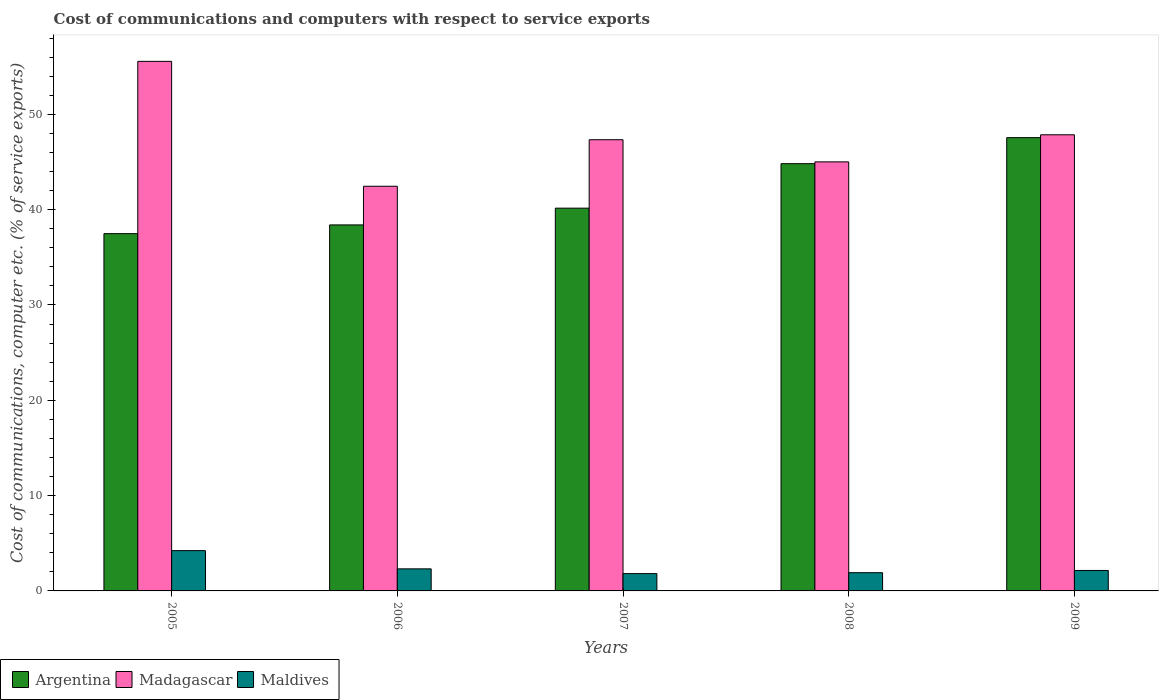How many groups of bars are there?
Your response must be concise. 5. Are the number of bars per tick equal to the number of legend labels?
Provide a succinct answer. Yes. In how many cases, is the number of bars for a given year not equal to the number of legend labels?
Offer a very short reply. 0. What is the cost of communications and computers in Maldives in 2007?
Your answer should be compact. 1.82. Across all years, what is the maximum cost of communications and computers in Madagascar?
Your answer should be compact. 55.56. Across all years, what is the minimum cost of communications and computers in Argentina?
Your answer should be compact. 37.49. In which year was the cost of communications and computers in Maldives maximum?
Offer a terse response. 2005. What is the total cost of communications and computers in Madagascar in the graph?
Offer a terse response. 238.24. What is the difference between the cost of communications and computers in Maldives in 2005 and that in 2006?
Your response must be concise. 1.91. What is the difference between the cost of communications and computers in Maldives in 2008 and the cost of communications and computers in Madagascar in 2006?
Provide a short and direct response. -40.55. What is the average cost of communications and computers in Madagascar per year?
Make the answer very short. 47.65. In the year 2006, what is the difference between the cost of communications and computers in Madagascar and cost of communications and computers in Maldives?
Your answer should be compact. 40.14. What is the ratio of the cost of communications and computers in Argentina in 2005 to that in 2009?
Give a very brief answer. 0.79. Is the difference between the cost of communications and computers in Madagascar in 2007 and 2008 greater than the difference between the cost of communications and computers in Maldives in 2007 and 2008?
Give a very brief answer. Yes. What is the difference between the highest and the second highest cost of communications and computers in Maldives?
Your answer should be compact. 1.91. What is the difference between the highest and the lowest cost of communications and computers in Argentina?
Make the answer very short. 10.07. In how many years, is the cost of communications and computers in Argentina greater than the average cost of communications and computers in Argentina taken over all years?
Offer a very short reply. 2. What does the 1st bar from the left in 2008 represents?
Keep it short and to the point. Argentina. How many years are there in the graph?
Offer a terse response. 5. What is the difference between two consecutive major ticks on the Y-axis?
Make the answer very short. 10. Where does the legend appear in the graph?
Offer a terse response. Bottom left. How many legend labels are there?
Your response must be concise. 3. What is the title of the graph?
Offer a very short reply. Cost of communications and computers with respect to service exports. Does "Iceland" appear as one of the legend labels in the graph?
Your answer should be compact. No. What is the label or title of the X-axis?
Offer a terse response. Years. What is the label or title of the Y-axis?
Your answer should be compact. Cost of communications, computer etc. (% of service exports). What is the Cost of communications, computer etc. (% of service exports) of Argentina in 2005?
Ensure brevity in your answer.  37.49. What is the Cost of communications, computer etc. (% of service exports) in Madagascar in 2005?
Give a very brief answer. 55.56. What is the Cost of communications, computer etc. (% of service exports) of Maldives in 2005?
Keep it short and to the point. 4.23. What is the Cost of communications, computer etc. (% of service exports) of Argentina in 2006?
Offer a terse response. 38.4. What is the Cost of communications, computer etc. (% of service exports) of Madagascar in 2006?
Your answer should be compact. 42.46. What is the Cost of communications, computer etc. (% of service exports) in Maldives in 2006?
Make the answer very short. 2.32. What is the Cost of communications, computer etc. (% of service exports) in Argentina in 2007?
Provide a succinct answer. 40.16. What is the Cost of communications, computer etc. (% of service exports) of Madagascar in 2007?
Give a very brief answer. 47.34. What is the Cost of communications, computer etc. (% of service exports) in Maldives in 2007?
Your answer should be very brief. 1.82. What is the Cost of communications, computer etc. (% of service exports) of Argentina in 2008?
Your response must be concise. 44.83. What is the Cost of communications, computer etc. (% of service exports) of Madagascar in 2008?
Your answer should be compact. 45.02. What is the Cost of communications, computer etc. (% of service exports) in Maldives in 2008?
Keep it short and to the point. 1.91. What is the Cost of communications, computer etc. (% of service exports) of Argentina in 2009?
Your response must be concise. 47.56. What is the Cost of communications, computer etc. (% of service exports) in Madagascar in 2009?
Provide a short and direct response. 47.86. What is the Cost of communications, computer etc. (% of service exports) in Maldives in 2009?
Provide a succinct answer. 2.15. Across all years, what is the maximum Cost of communications, computer etc. (% of service exports) of Argentina?
Provide a short and direct response. 47.56. Across all years, what is the maximum Cost of communications, computer etc. (% of service exports) in Madagascar?
Your response must be concise. 55.56. Across all years, what is the maximum Cost of communications, computer etc. (% of service exports) of Maldives?
Keep it short and to the point. 4.23. Across all years, what is the minimum Cost of communications, computer etc. (% of service exports) in Argentina?
Your response must be concise. 37.49. Across all years, what is the minimum Cost of communications, computer etc. (% of service exports) in Madagascar?
Offer a very short reply. 42.46. Across all years, what is the minimum Cost of communications, computer etc. (% of service exports) of Maldives?
Your answer should be compact. 1.82. What is the total Cost of communications, computer etc. (% of service exports) of Argentina in the graph?
Offer a terse response. 208.43. What is the total Cost of communications, computer etc. (% of service exports) of Madagascar in the graph?
Your response must be concise. 238.24. What is the total Cost of communications, computer etc. (% of service exports) of Maldives in the graph?
Make the answer very short. 12.42. What is the difference between the Cost of communications, computer etc. (% of service exports) of Argentina in 2005 and that in 2006?
Offer a very short reply. -0.92. What is the difference between the Cost of communications, computer etc. (% of service exports) of Madagascar in 2005 and that in 2006?
Keep it short and to the point. 13.1. What is the difference between the Cost of communications, computer etc. (% of service exports) in Maldives in 2005 and that in 2006?
Offer a terse response. 1.91. What is the difference between the Cost of communications, computer etc. (% of service exports) of Argentina in 2005 and that in 2007?
Ensure brevity in your answer.  -2.67. What is the difference between the Cost of communications, computer etc. (% of service exports) of Madagascar in 2005 and that in 2007?
Ensure brevity in your answer.  8.22. What is the difference between the Cost of communications, computer etc. (% of service exports) of Maldives in 2005 and that in 2007?
Your answer should be compact. 2.41. What is the difference between the Cost of communications, computer etc. (% of service exports) in Argentina in 2005 and that in 2008?
Ensure brevity in your answer.  -7.34. What is the difference between the Cost of communications, computer etc. (% of service exports) of Madagascar in 2005 and that in 2008?
Give a very brief answer. 10.55. What is the difference between the Cost of communications, computer etc. (% of service exports) in Maldives in 2005 and that in 2008?
Your response must be concise. 2.32. What is the difference between the Cost of communications, computer etc. (% of service exports) of Argentina in 2005 and that in 2009?
Make the answer very short. -10.07. What is the difference between the Cost of communications, computer etc. (% of service exports) of Madagascar in 2005 and that in 2009?
Make the answer very short. 7.7. What is the difference between the Cost of communications, computer etc. (% of service exports) in Maldives in 2005 and that in 2009?
Offer a very short reply. 2.08. What is the difference between the Cost of communications, computer etc. (% of service exports) in Argentina in 2006 and that in 2007?
Your response must be concise. -1.76. What is the difference between the Cost of communications, computer etc. (% of service exports) in Madagascar in 2006 and that in 2007?
Provide a short and direct response. -4.88. What is the difference between the Cost of communications, computer etc. (% of service exports) in Maldives in 2006 and that in 2007?
Offer a very short reply. 0.5. What is the difference between the Cost of communications, computer etc. (% of service exports) of Argentina in 2006 and that in 2008?
Ensure brevity in your answer.  -6.42. What is the difference between the Cost of communications, computer etc. (% of service exports) of Madagascar in 2006 and that in 2008?
Offer a terse response. -2.56. What is the difference between the Cost of communications, computer etc. (% of service exports) of Maldives in 2006 and that in 2008?
Offer a very short reply. 0.4. What is the difference between the Cost of communications, computer etc. (% of service exports) of Argentina in 2006 and that in 2009?
Offer a terse response. -9.16. What is the difference between the Cost of communications, computer etc. (% of service exports) in Madagascar in 2006 and that in 2009?
Give a very brief answer. -5.4. What is the difference between the Cost of communications, computer etc. (% of service exports) of Maldives in 2006 and that in 2009?
Offer a terse response. 0.17. What is the difference between the Cost of communications, computer etc. (% of service exports) of Argentina in 2007 and that in 2008?
Provide a succinct answer. -4.67. What is the difference between the Cost of communications, computer etc. (% of service exports) in Madagascar in 2007 and that in 2008?
Keep it short and to the point. 2.32. What is the difference between the Cost of communications, computer etc. (% of service exports) of Maldives in 2007 and that in 2008?
Ensure brevity in your answer.  -0.09. What is the difference between the Cost of communications, computer etc. (% of service exports) of Argentina in 2007 and that in 2009?
Make the answer very short. -7.4. What is the difference between the Cost of communications, computer etc. (% of service exports) in Madagascar in 2007 and that in 2009?
Make the answer very short. -0.52. What is the difference between the Cost of communications, computer etc. (% of service exports) in Maldives in 2007 and that in 2009?
Give a very brief answer. -0.33. What is the difference between the Cost of communications, computer etc. (% of service exports) in Argentina in 2008 and that in 2009?
Make the answer very short. -2.73. What is the difference between the Cost of communications, computer etc. (% of service exports) of Madagascar in 2008 and that in 2009?
Provide a succinct answer. -2.84. What is the difference between the Cost of communications, computer etc. (% of service exports) of Maldives in 2008 and that in 2009?
Offer a very short reply. -0.24. What is the difference between the Cost of communications, computer etc. (% of service exports) of Argentina in 2005 and the Cost of communications, computer etc. (% of service exports) of Madagascar in 2006?
Provide a succinct answer. -4.97. What is the difference between the Cost of communications, computer etc. (% of service exports) in Argentina in 2005 and the Cost of communications, computer etc. (% of service exports) in Maldives in 2006?
Offer a very short reply. 35.17. What is the difference between the Cost of communications, computer etc. (% of service exports) of Madagascar in 2005 and the Cost of communications, computer etc. (% of service exports) of Maldives in 2006?
Keep it short and to the point. 53.25. What is the difference between the Cost of communications, computer etc. (% of service exports) of Argentina in 2005 and the Cost of communications, computer etc. (% of service exports) of Madagascar in 2007?
Make the answer very short. -9.86. What is the difference between the Cost of communications, computer etc. (% of service exports) of Argentina in 2005 and the Cost of communications, computer etc. (% of service exports) of Maldives in 2007?
Offer a very short reply. 35.67. What is the difference between the Cost of communications, computer etc. (% of service exports) of Madagascar in 2005 and the Cost of communications, computer etc. (% of service exports) of Maldives in 2007?
Provide a succinct answer. 53.75. What is the difference between the Cost of communications, computer etc. (% of service exports) of Argentina in 2005 and the Cost of communications, computer etc. (% of service exports) of Madagascar in 2008?
Offer a very short reply. -7.53. What is the difference between the Cost of communications, computer etc. (% of service exports) in Argentina in 2005 and the Cost of communications, computer etc. (% of service exports) in Maldives in 2008?
Provide a short and direct response. 35.57. What is the difference between the Cost of communications, computer etc. (% of service exports) of Madagascar in 2005 and the Cost of communications, computer etc. (% of service exports) of Maldives in 2008?
Your response must be concise. 53.65. What is the difference between the Cost of communications, computer etc. (% of service exports) of Argentina in 2005 and the Cost of communications, computer etc. (% of service exports) of Madagascar in 2009?
Offer a very short reply. -10.37. What is the difference between the Cost of communications, computer etc. (% of service exports) of Argentina in 2005 and the Cost of communications, computer etc. (% of service exports) of Maldives in 2009?
Offer a terse response. 35.34. What is the difference between the Cost of communications, computer etc. (% of service exports) of Madagascar in 2005 and the Cost of communications, computer etc. (% of service exports) of Maldives in 2009?
Keep it short and to the point. 53.42. What is the difference between the Cost of communications, computer etc. (% of service exports) in Argentina in 2006 and the Cost of communications, computer etc. (% of service exports) in Madagascar in 2007?
Offer a very short reply. -8.94. What is the difference between the Cost of communications, computer etc. (% of service exports) in Argentina in 2006 and the Cost of communications, computer etc. (% of service exports) in Maldives in 2007?
Ensure brevity in your answer.  36.58. What is the difference between the Cost of communications, computer etc. (% of service exports) of Madagascar in 2006 and the Cost of communications, computer etc. (% of service exports) of Maldives in 2007?
Give a very brief answer. 40.64. What is the difference between the Cost of communications, computer etc. (% of service exports) of Argentina in 2006 and the Cost of communications, computer etc. (% of service exports) of Madagascar in 2008?
Give a very brief answer. -6.61. What is the difference between the Cost of communications, computer etc. (% of service exports) of Argentina in 2006 and the Cost of communications, computer etc. (% of service exports) of Maldives in 2008?
Provide a short and direct response. 36.49. What is the difference between the Cost of communications, computer etc. (% of service exports) of Madagascar in 2006 and the Cost of communications, computer etc. (% of service exports) of Maldives in 2008?
Make the answer very short. 40.55. What is the difference between the Cost of communications, computer etc. (% of service exports) of Argentina in 2006 and the Cost of communications, computer etc. (% of service exports) of Madagascar in 2009?
Your answer should be very brief. -9.46. What is the difference between the Cost of communications, computer etc. (% of service exports) in Argentina in 2006 and the Cost of communications, computer etc. (% of service exports) in Maldives in 2009?
Offer a very short reply. 36.26. What is the difference between the Cost of communications, computer etc. (% of service exports) of Madagascar in 2006 and the Cost of communications, computer etc. (% of service exports) of Maldives in 2009?
Offer a very short reply. 40.31. What is the difference between the Cost of communications, computer etc. (% of service exports) of Argentina in 2007 and the Cost of communications, computer etc. (% of service exports) of Madagascar in 2008?
Your answer should be very brief. -4.86. What is the difference between the Cost of communications, computer etc. (% of service exports) in Argentina in 2007 and the Cost of communications, computer etc. (% of service exports) in Maldives in 2008?
Keep it short and to the point. 38.25. What is the difference between the Cost of communications, computer etc. (% of service exports) in Madagascar in 2007 and the Cost of communications, computer etc. (% of service exports) in Maldives in 2008?
Make the answer very short. 45.43. What is the difference between the Cost of communications, computer etc. (% of service exports) of Argentina in 2007 and the Cost of communications, computer etc. (% of service exports) of Madagascar in 2009?
Provide a short and direct response. -7.7. What is the difference between the Cost of communications, computer etc. (% of service exports) in Argentina in 2007 and the Cost of communications, computer etc. (% of service exports) in Maldives in 2009?
Offer a terse response. 38.01. What is the difference between the Cost of communications, computer etc. (% of service exports) of Madagascar in 2007 and the Cost of communications, computer etc. (% of service exports) of Maldives in 2009?
Offer a terse response. 45.19. What is the difference between the Cost of communications, computer etc. (% of service exports) of Argentina in 2008 and the Cost of communications, computer etc. (% of service exports) of Madagascar in 2009?
Keep it short and to the point. -3.03. What is the difference between the Cost of communications, computer etc. (% of service exports) in Argentina in 2008 and the Cost of communications, computer etc. (% of service exports) in Maldives in 2009?
Give a very brief answer. 42.68. What is the difference between the Cost of communications, computer etc. (% of service exports) in Madagascar in 2008 and the Cost of communications, computer etc. (% of service exports) in Maldives in 2009?
Make the answer very short. 42.87. What is the average Cost of communications, computer etc. (% of service exports) of Argentina per year?
Offer a very short reply. 41.69. What is the average Cost of communications, computer etc. (% of service exports) in Madagascar per year?
Make the answer very short. 47.65. What is the average Cost of communications, computer etc. (% of service exports) in Maldives per year?
Ensure brevity in your answer.  2.48. In the year 2005, what is the difference between the Cost of communications, computer etc. (% of service exports) of Argentina and Cost of communications, computer etc. (% of service exports) of Madagascar?
Provide a short and direct response. -18.08. In the year 2005, what is the difference between the Cost of communications, computer etc. (% of service exports) of Argentina and Cost of communications, computer etc. (% of service exports) of Maldives?
Your response must be concise. 33.26. In the year 2005, what is the difference between the Cost of communications, computer etc. (% of service exports) of Madagascar and Cost of communications, computer etc. (% of service exports) of Maldives?
Give a very brief answer. 51.34. In the year 2006, what is the difference between the Cost of communications, computer etc. (% of service exports) in Argentina and Cost of communications, computer etc. (% of service exports) in Madagascar?
Give a very brief answer. -4.06. In the year 2006, what is the difference between the Cost of communications, computer etc. (% of service exports) in Argentina and Cost of communications, computer etc. (% of service exports) in Maldives?
Your answer should be very brief. 36.09. In the year 2006, what is the difference between the Cost of communications, computer etc. (% of service exports) of Madagascar and Cost of communications, computer etc. (% of service exports) of Maldives?
Your answer should be compact. 40.14. In the year 2007, what is the difference between the Cost of communications, computer etc. (% of service exports) of Argentina and Cost of communications, computer etc. (% of service exports) of Madagascar?
Make the answer very short. -7.18. In the year 2007, what is the difference between the Cost of communications, computer etc. (% of service exports) of Argentina and Cost of communications, computer etc. (% of service exports) of Maldives?
Offer a terse response. 38.34. In the year 2007, what is the difference between the Cost of communications, computer etc. (% of service exports) of Madagascar and Cost of communications, computer etc. (% of service exports) of Maldives?
Provide a succinct answer. 45.52. In the year 2008, what is the difference between the Cost of communications, computer etc. (% of service exports) of Argentina and Cost of communications, computer etc. (% of service exports) of Madagascar?
Provide a succinct answer. -0.19. In the year 2008, what is the difference between the Cost of communications, computer etc. (% of service exports) of Argentina and Cost of communications, computer etc. (% of service exports) of Maldives?
Offer a very short reply. 42.91. In the year 2008, what is the difference between the Cost of communications, computer etc. (% of service exports) of Madagascar and Cost of communications, computer etc. (% of service exports) of Maldives?
Provide a short and direct response. 43.1. In the year 2009, what is the difference between the Cost of communications, computer etc. (% of service exports) of Argentina and Cost of communications, computer etc. (% of service exports) of Madagascar?
Your answer should be compact. -0.3. In the year 2009, what is the difference between the Cost of communications, computer etc. (% of service exports) in Argentina and Cost of communications, computer etc. (% of service exports) in Maldives?
Your response must be concise. 45.41. In the year 2009, what is the difference between the Cost of communications, computer etc. (% of service exports) of Madagascar and Cost of communications, computer etc. (% of service exports) of Maldives?
Make the answer very short. 45.71. What is the ratio of the Cost of communications, computer etc. (% of service exports) of Argentina in 2005 to that in 2006?
Give a very brief answer. 0.98. What is the ratio of the Cost of communications, computer etc. (% of service exports) in Madagascar in 2005 to that in 2006?
Make the answer very short. 1.31. What is the ratio of the Cost of communications, computer etc. (% of service exports) of Maldives in 2005 to that in 2006?
Keep it short and to the point. 1.83. What is the ratio of the Cost of communications, computer etc. (% of service exports) in Argentina in 2005 to that in 2007?
Provide a short and direct response. 0.93. What is the ratio of the Cost of communications, computer etc. (% of service exports) in Madagascar in 2005 to that in 2007?
Your answer should be compact. 1.17. What is the ratio of the Cost of communications, computer etc. (% of service exports) of Maldives in 2005 to that in 2007?
Provide a short and direct response. 2.33. What is the ratio of the Cost of communications, computer etc. (% of service exports) of Argentina in 2005 to that in 2008?
Your answer should be very brief. 0.84. What is the ratio of the Cost of communications, computer etc. (% of service exports) in Madagascar in 2005 to that in 2008?
Give a very brief answer. 1.23. What is the ratio of the Cost of communications, computer etc. (% of service exports) in Maldives in 2005 to that in 2008?
Provide a succinct answer. 2.21. What is the ratio of the Cost of communications, computer etc. (% of service exports) in Argentina in 2005 to that in 2009?
Make the answer very short. 0.79. What is the ratio of the Cost of communications, computer etc. (% of service exports) of Madagascar in 2005 to that in 2009?
Your answer should be compact. 1.16. What is the ratio of the Cost of communications, computer etc. (% of service exports) in Maldives in 2005 to that in 2009?
Make the answer very short. 1.97. What is the ratio of the Cost of communications, computer etc. (% of service exports) of Argentina in 2006 to that in 2007?
Provide a succinct answer. 0.96. What is the ratio of the Cost of communications, computer etc. (% of service exports) in Madagascar in 2006 to that in 2007?
Keep it short and to the point. 0.9. What is the ratio of the Cost of communications, computer etc. (% of service exports) in Maldives in 2006 to that in 2007?
Keep it short and to the point. 1.27. What is the ratio of the Cost of communications, computer etc. (% of service exports) in Argentina in 2006 to that in 2008?
Offer a very short reply. 0.86. What is the ratio of the Cost of communications, computer etc. (% of service exports) in Madagascar in 2006 to that in 2008?
Make the answer very short. 0.94. What is the ratio of the Cost of communications, computer etc. (% of service exports) of Maldives in 2006 to that in 2008?
Give a very brief answer. 1.21. What is the ratio of the Cost of communications, computer etc. (% of service exports) in Argentina in 2006 to that in 2009?
Provide a short and direct response. 0.81. What is the ratio of the Cost of communications, computer etc. (% of service exports) of Madagascar in 2006 to that in 2009?
Give a very brief answer. 0.89. What is the ratio of the Cost of communications, computer etc. (% of service exports) of Maldives in 2006 to that in 2009?
Offer a terse response. 1.08. What is the ratio of the Cost of communications, computer etc. (% of service exports) in Argentina in 2007 to that in 2008?
Provide a succinct answer. 0.9. What is the ratio of the Cost of communications, computer etc. (% of service exports) of Madagascar in 2007 to that in 2008?
Your answer should be compact. 1.05. What is the ratio of the Cost of communications, computer etc. (% of service exports) of Maldives in 2007 to that in 2008?
Your response must be concise. 0.95. What is the ratio of the Cost of communications, computer etc. (% of service exports) of Argentina in 2007 to that in 2009?
Ensure brevity in your answer.  0.84. What is the ratio of the Cost of communications, computer etc. (% of service exports) in Maldives in 2007 to that in 2009?
Ensure brevity in your answer.  0.85. What is the ratio of the Cost of communications, computer etc. (% of service exports) in Argentina in 2008 to that in 2009?
Make the answer very short. 0.94. What is the ratio of the Cost of communications, computer etc. (% of service exports) of Madagascar in 2008 to that in 2009?
Make the answer very short. 0.94. What is the ratio of the Cost of communications, computer etc. (% of service exports) in Maldives in 2008 to that in 2009?
Provide a succinct answer. 0.89. What is the difference between the highest and the second highest Cost of communications, computer etc. (% of service exports) in Argentina?
Your answer should be very brief. 2.73. What is the difference between the highest and the second highest Cost of communications, computer etc. (% of service exports) of Madagascar?
Ensure brevity in your answer.  7.7. What is the difference between the highest and the second highest Cost of communications, computer etc. (% of service exports) of Maldives?
Your answer should be very brief. 1.91. What is the difference between the highest and the lowest Cost of communications, computer etc. (% of service exports) in Argentina?
Your answer should be compact. 10.07. What is the difference between the highest and the lowest Cost of communications, computer etc. (% of service exports) in Madagascar?
Keep it short and to the point. 13.1. What is the difference between the highest and the lowest Cost of communications, computer etc. (% of service exports) of Maldives?
Keep it short and to the point. 2.41. 